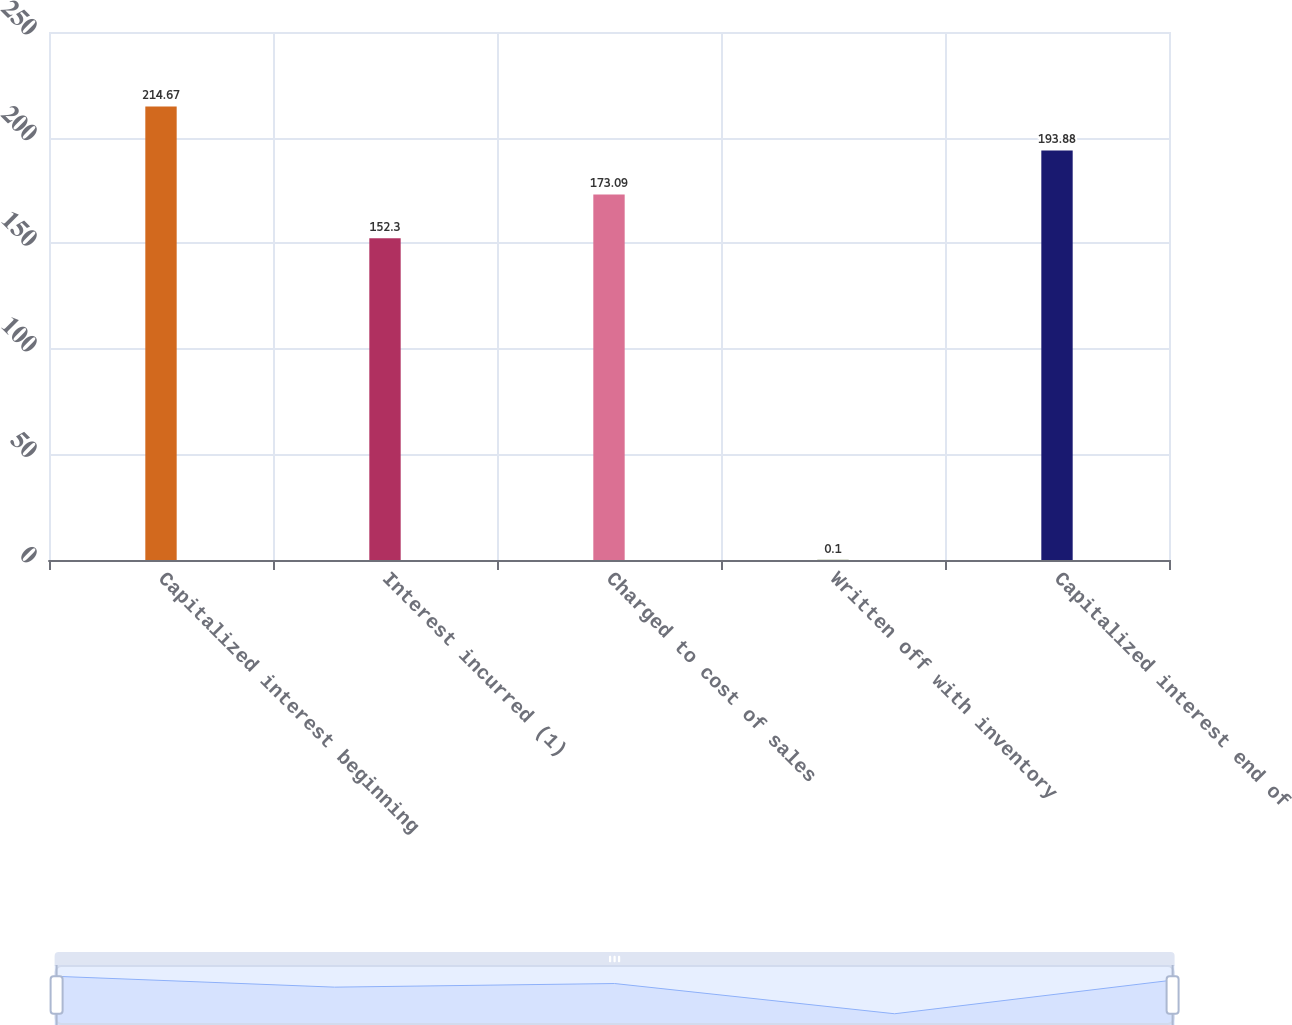Convert chart. <chart><loc_0><loc_0><loc_500><loc_500><bar_chart><fcel>Capitalized interest beginning<fcel>Interest incurred (1)<fcel>Charged to cost of sales<fcel>Written off with inventory<fcel>Capitalized interest end of<nl><fcel>214.67<fcel>152.3<fcel>173.09<fcel>0.1<fcel>193.88<nl></chart> 